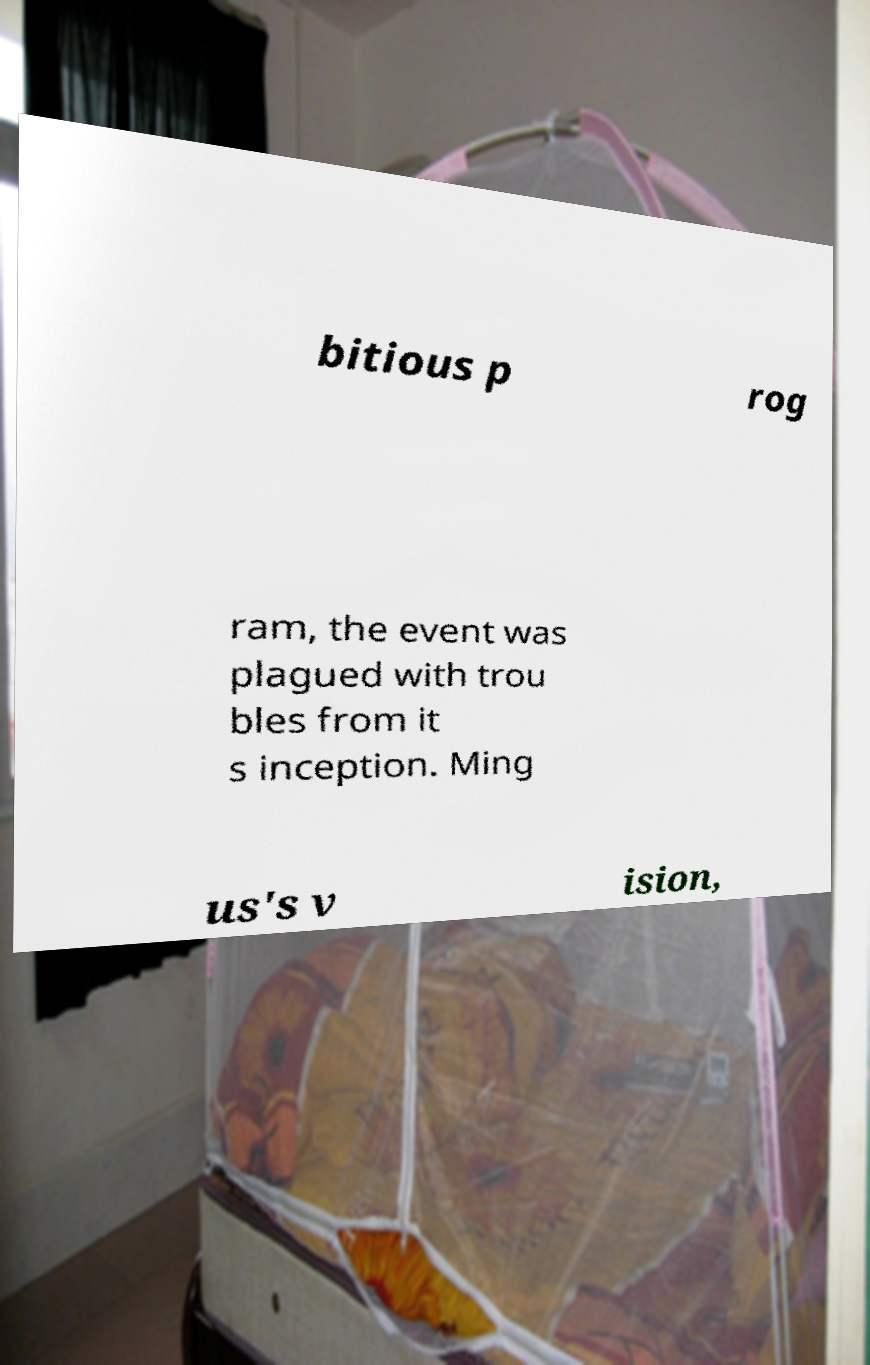Please identify and transcribe the text found in this image. bitious p rog ram, the event was plagued with trou bles from it s inception. Ming us's v ision, 